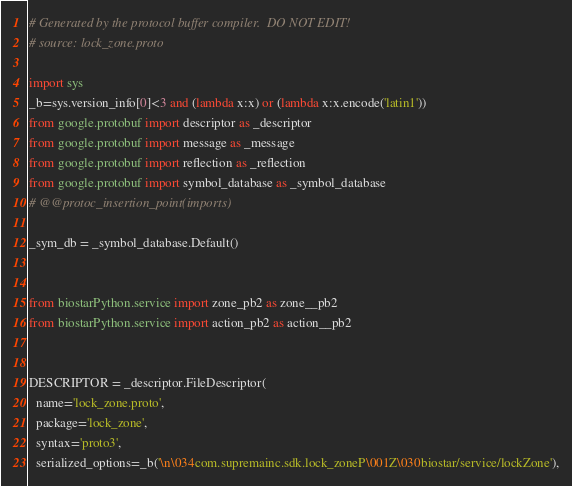<code> <loc_0><loc_0><loc_500><loc_500><_Python_># Generated by the protocol buffer compiler.  DO NOT EDIT!
# source: lock_zone.proto

import sys
_b=sys.version_info[0]<3 and (lambda x:x) or (lambda x:x.encode('latin1'))
from google.protobuf import descriptor as _descriptor
from google.protobuf import message as _message
from google.protobuf import reflection as _reflection
from google.protobuf import symbol_database as _symbol_database
# @@protoc_insertion_point(imports)

_sym_db = _symbol_database.Default()


from biostarPython.service import zone_pb2 as zone__pb2
from biostarPython.service import action_pb2 as action__pb2


DESCRIPTOR = _descriptor.FileDescriptor(
  name='lock_zone.proto',
  package='lock_zone',
  syntax='proto3',
  serialized_options=_b('\n\034com.supremainc.sdk.lock_zoneP\001Z\030biostar/service/lockZone'),</code> 